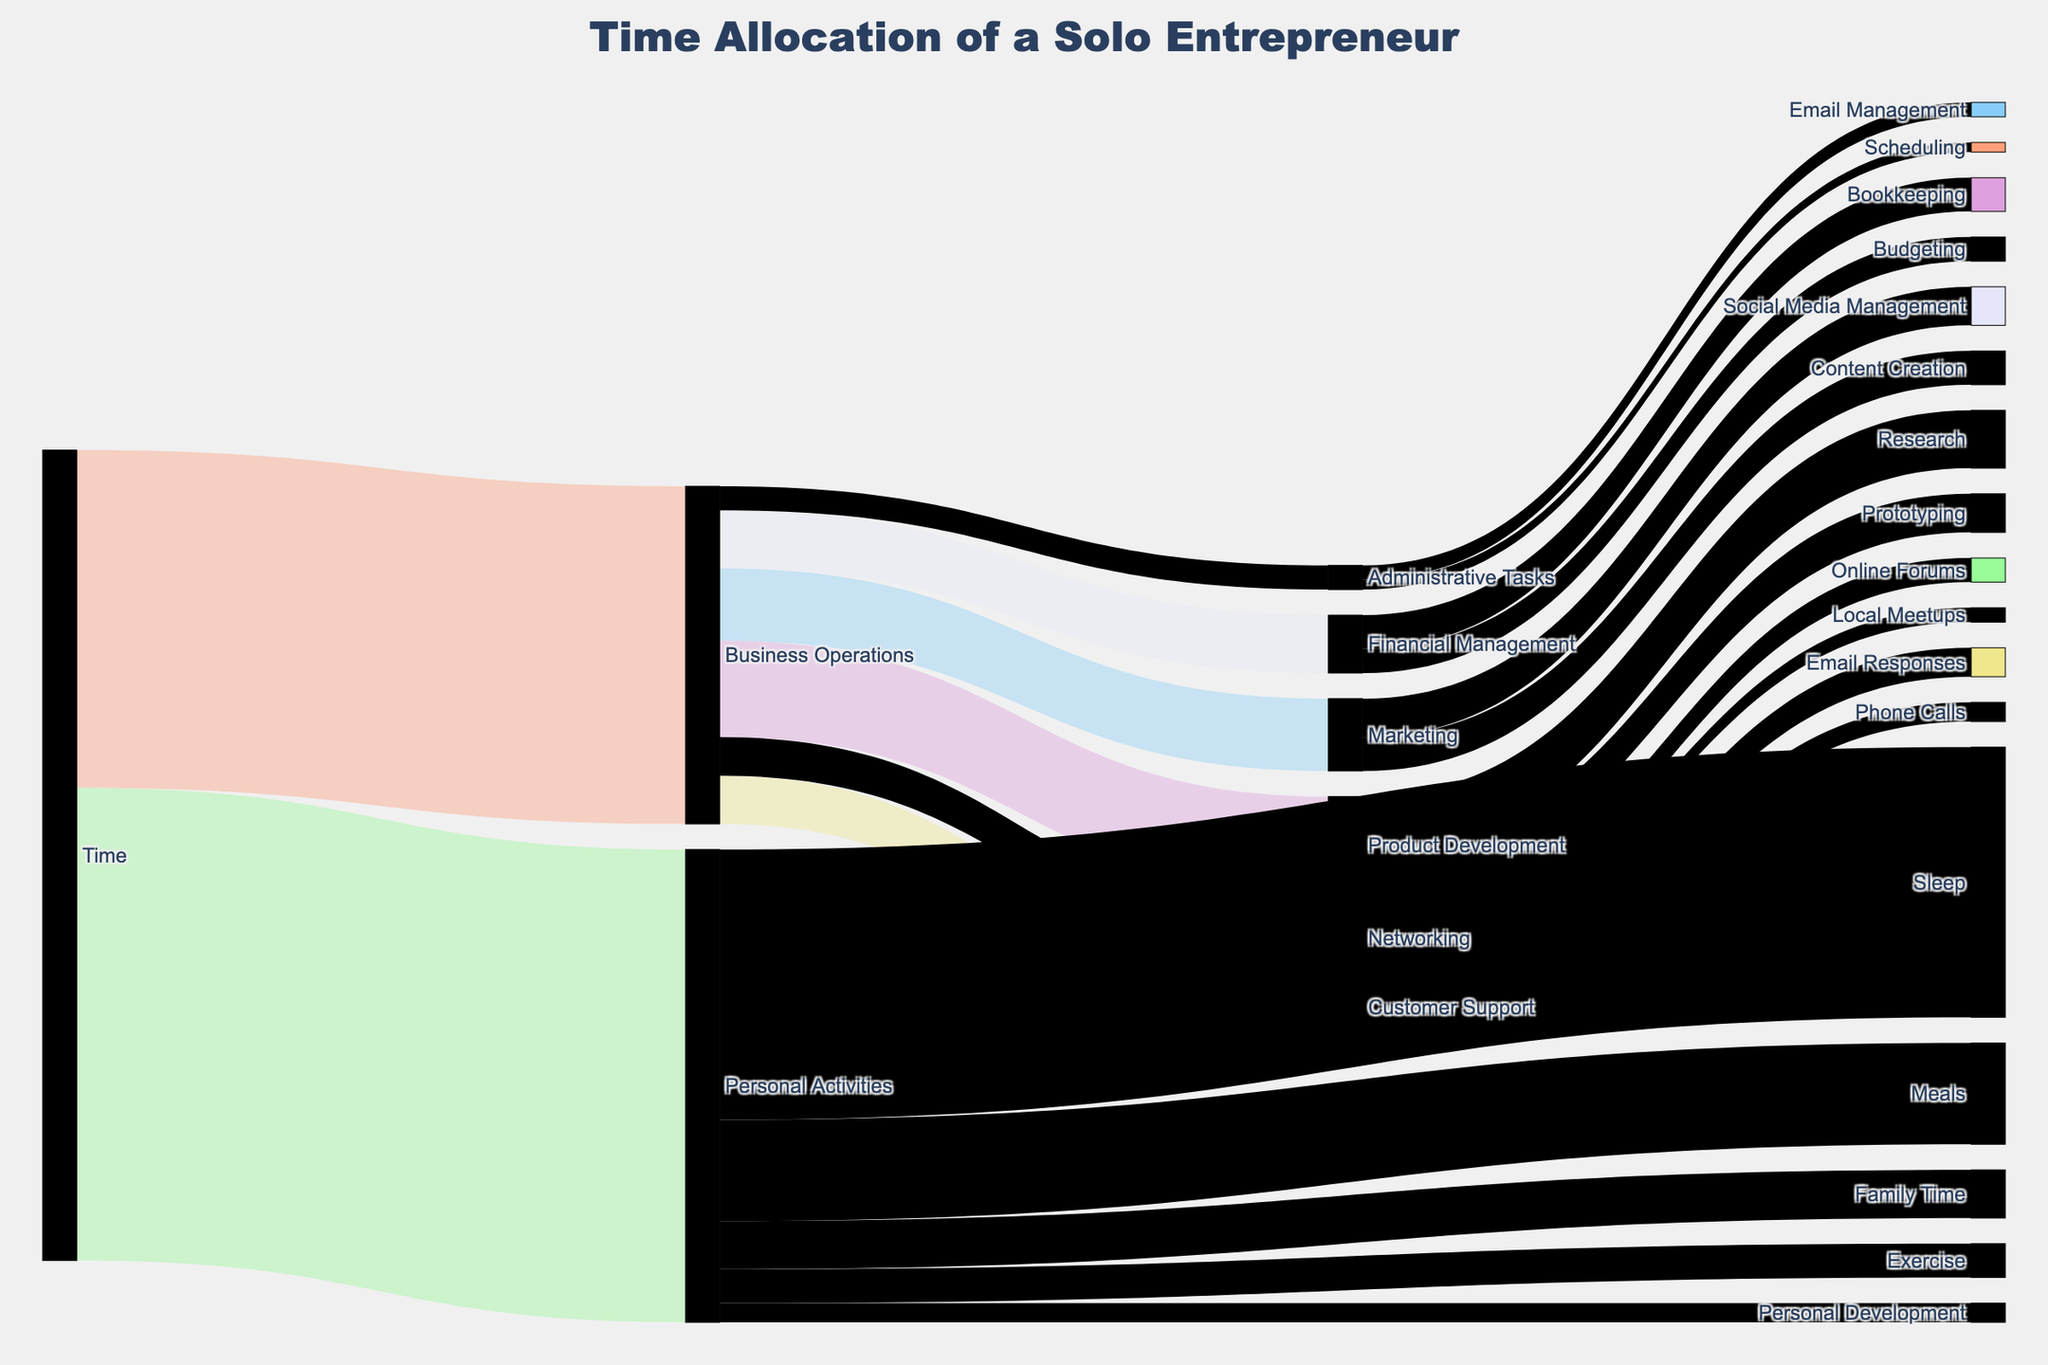What's the total time allocated to Business Operations and Personal Activities? To find the total time, sum the values for Business Operations and Personal Activities, which are 70 and 98, respectively. So the total time is 70 + 98 = 168 hours.
Answer: 168 hours How many hours are spent on Marketing activities? The figure shows Marketing branching into Social Media Management and Content Creation with values of 8 and 7 hours, respectively. Adding these together gives 8 + 7 = 15 hours.
Answer: 15 hours Which task under Business Operations takes the most time? Among the tasks under Business Operations, Product Development takes the most time with 20 hours.
Answer: Product Development How does the time spent on Email Responses compare to Phone Calls in Customer Support? For Customer Support, Email Responses take 6 hours, while Phone Calls take 4 hours. Comparing them, 6 is more than 4.
Answer: Email Responses take more time What is the total time spent on meals in a week? The time allocated to Meals under Personal Activities is directly given as 21 hours.
Answer: 21 hours How does time spent on Product Development compare to Networking? Product Development takes 20 hours. Networking takes (Online Forums 5 hours + Local Meetups 3 hours) = 8 hours. Comparing them, 20 is more than 8.
Answer: Product Development takes more time What is the proportion of time spent on Sleep out of Personal Activities? Time spent on Sleep is 56 hours, and the total time on Personal Activities is 98 hours. The proportion is calculated as 56/98 = 0.571, or 57.1%.
Answer: 57.1% How many hours are dedicated to Administrative Tasks? Administrative Tasks are divided into Email Management and Scheduling with 3 and 2 hours, respectively. Adding these together gives 3 + 2 = 5 hours.
Answer: 5 hours Which has more time allocated: Meals or Exercise? Meals have 21 hours whereas Exercise has 7 hours. Comparing them, 21 is more than 7.
Answer: Meals have more time Which task within Financial Management takes the least time? Within Financial Management, Bookkeeping takes 7 hours and Budgeting takes 5 hours. Budgeting takes the least time.
Answer: Budgeting 